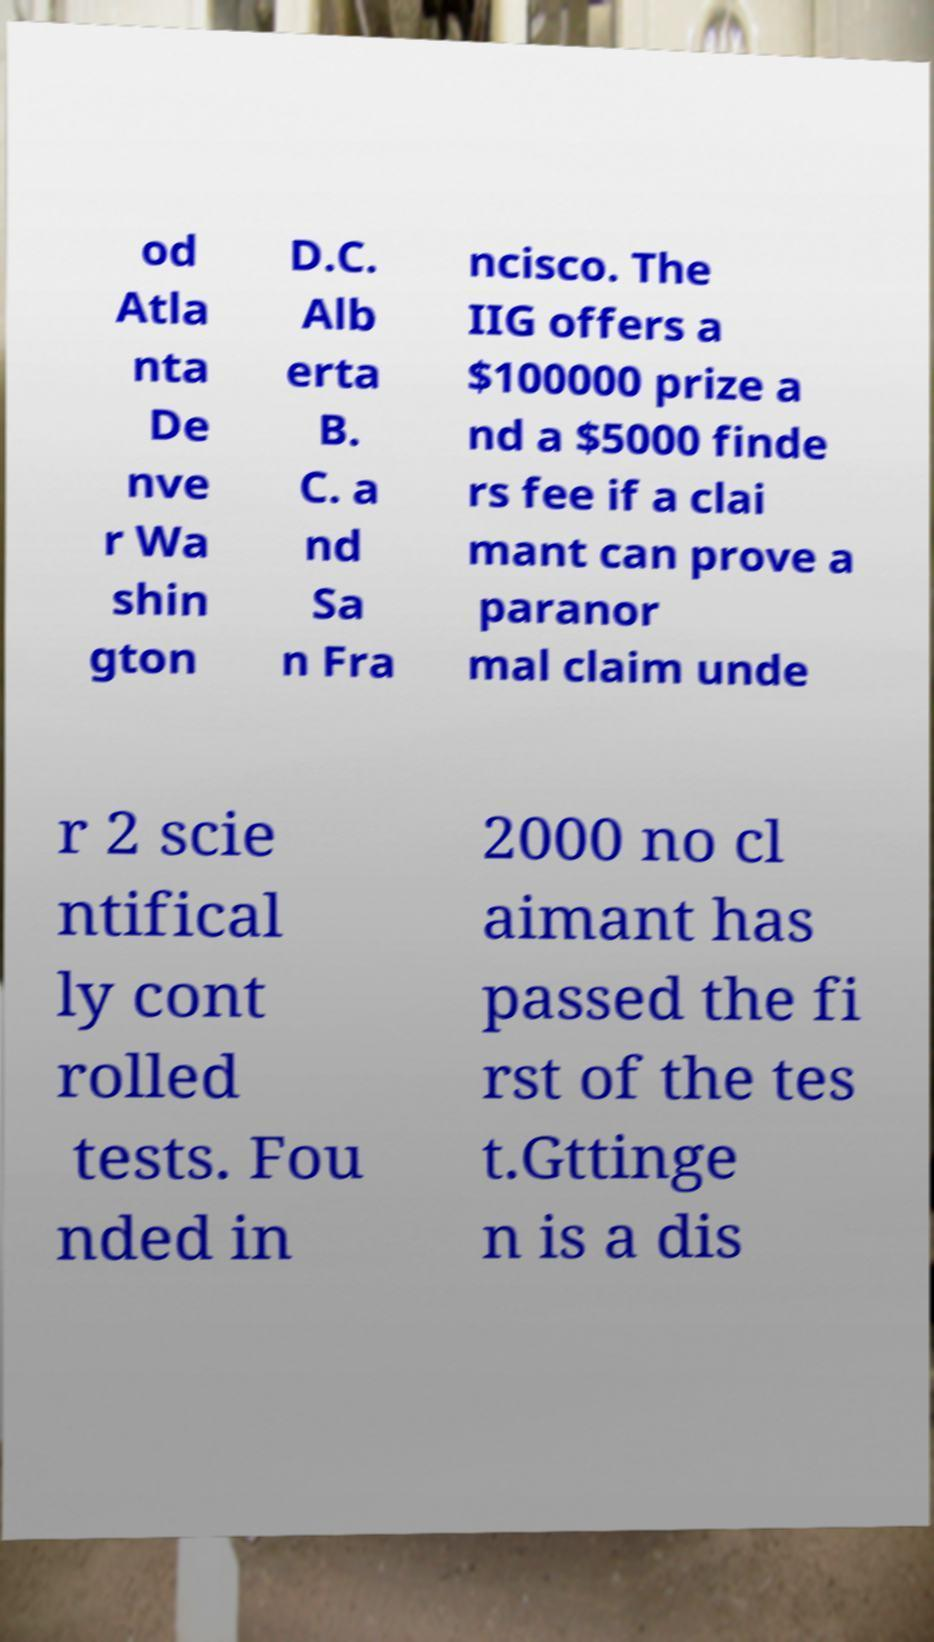Please read and relay the text visible in this image. What does it say? od Atla nta De nve r Wa shin gton D.C. Alb erta B. C. a nd Sa n Fra ncisco. The IIG offers a $100000 prize a nd a $5000 finde rs fee if a clai mant can prove a paranor mal claim unde r 2 scie ntifical ly cont rolled tests. Fou nded in 2000 no cl aimant has passed the fi rst of the tes t.Gttinge n is a dis 